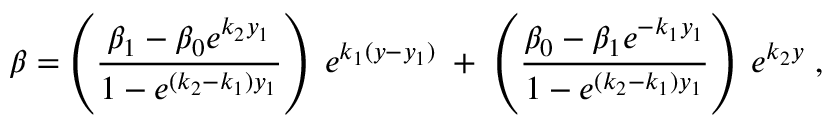Convert formula to latex. <formula><loc_0><loc_0><loc_500><loc_500>\beta = \left ( \frac { \beta _ { 1 } - \beta _ { 0 } e ^ { k _ { 2 } y _ { 1 } } } { 1 - e ^ { ( k _ { 2 } - k _ { 1 } ) y _ { 1 } } } \right ) \, e ^ { k _ { 1 } ( y - y _ { 1 } ) } \, + \, \left ( \frac { \beta _ { 0 } - \beta _ { 1 } e ^ { - k _ { 1 } y _ { 1 } } } { 1 - e ^ { ( k _ { 2 } - k _ { 1 } ) y _ { 1 } } } \right ) \, e ^ { k _ { 2 } y } \, ,</formula> 